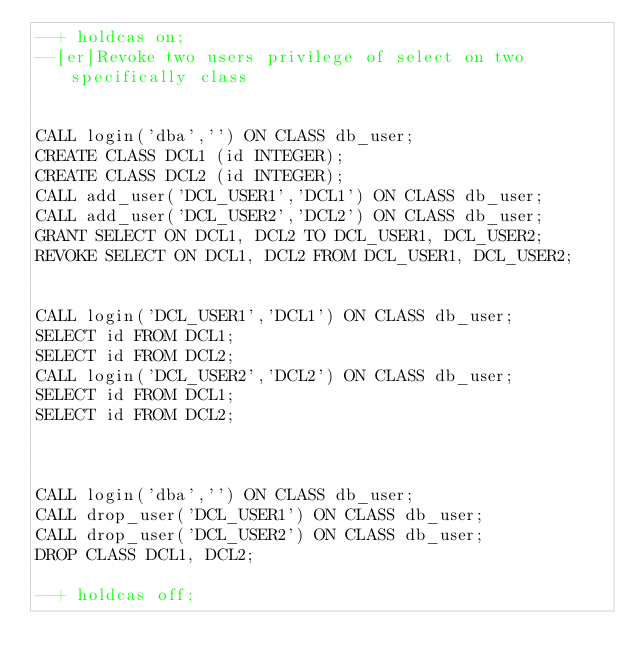Convert code to text. <code><loc_0><loc_0><loc_500><loc_500><_SQL_>--+ holdcas on;
--[er]Revoke two users privilege of select on two specifically class


CALL login('dba','') ON CLASS db_user;
CREATE CLASS DCL1 (id INTEGER);
CREATE CLASS DCL2 (id INTEGER);
CALL add_user('DCL_USER1','DCL1') ON CLASS db_user;
CALL add_user('DCL_USER2','DCL2') ON CLASS db_user;
GRANT SELECT ON DCL1, DCL2 TO DCL_USER1, DCL_USER2;
REVOKE SELECT ON DCL1, DCL2 FROM DCL_USER1, DCL_USER2;


CALL login('DCL_USER1','DCL1') ON CLASS db_user;
SELECT id FROM DCL1;
SELECT id FROM DCL2;
CALL login('DCL_USER2','DCL2') ON CLASS db_user;
SELECT id FROM DCL1;
SELECT id FROM DCL2;



CALL login('dba','') ON CLASS db_user;
CALL drop_user('DCL_USER1') ON CLASS db_user;
CALL drop_user('DCL_USER2') ON CLASS db_user;
DROP CLASS DCL1, DCL2;

--+ holdcas off;
</code> 